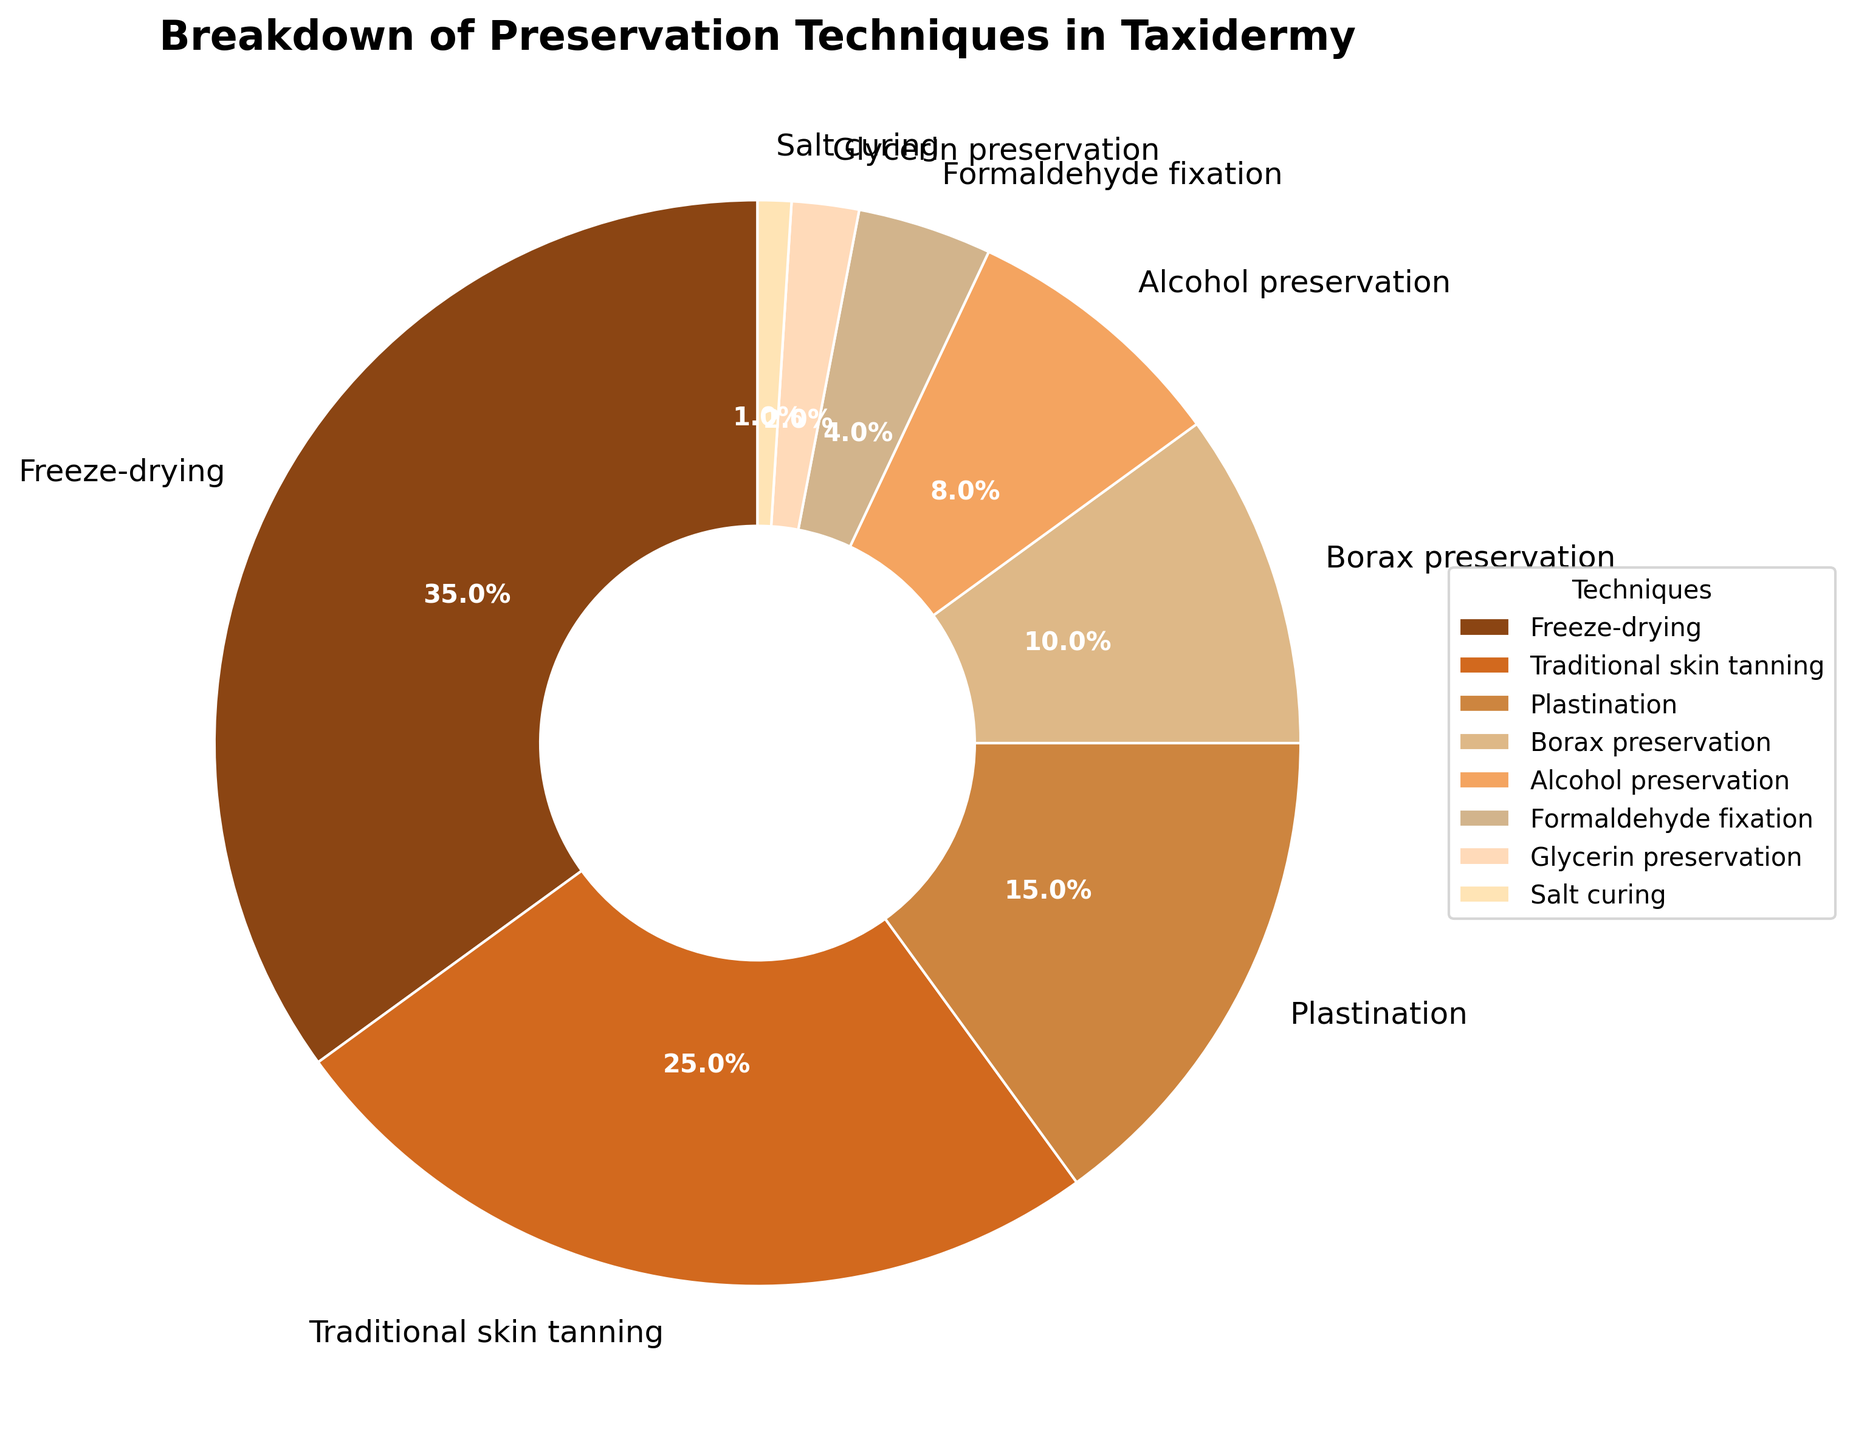What technique has the highest percentage of usage? The pie chart indicates the percentage of each preservation technique. Freeze-drying has the highest percentage slice.
Answer: Freeze-drying Which two techniques combined account for 40 percent of the total usage? First, note the percentages for each technique and find two that sum to 40. Borax preservation (10%) and Alcohol preservation (8%) together add up to 18%, so they are not the answer. Then, check Traditional skin tanning (25%) and Plastination (15%). These equal 40%.
Answer: Traditional skin tanning and Plastination How much more popular is Freeze-drying compared to Plastination? Freeze-drying has 35% usage, while Plastination has 15%. Subtract the percentage of Plastination from Freeze-drying. 35% - 15% = 20%.
Answer: 20% Which technique is represented by the color that is darkest? The pie chart uses various shades to represent different techniques. The darkest color corresponds to Freeze-drying, which is shown with the darkest brown.
Answer: Freeze-drying Are there any techniques that have a single-digit percentage, and if so, which ones? Identify techniques with percentages less than 10%. The techniques with such percentages are Alcohol preservation (8%), Formaldehyde fixation (4%), Glycerin preservation (2%), and Salt curing (1%).
Answer: Alcohol preservation, Formaldehyde fixation, Glycerin preservation, Salt curing What's the combined percentage of all the techniques with single-digit usage? Sum the percentages for Alcohol preservation (8%), Formaldehyde fixation (4%), Glycerin preservation (2%), and Salt curing (1%). 8% + 4% + 2% + 1% = 15%.
Answer: 15% What is the difference in usage percentage between Traditional skin tanning and Borax preservation? The percentage for Traditional skin tanning is 25%, and for Borax preservation is 10%. Subtract Borax preservation from Traditional skin tanning. 25% - 10% = 15%.
Answer: 15% Which preservation techniques have a higher usage percentage than Alcohol preservation? Alcohol preservation has a usage percentage of 8%. The techniques with higher usage are Freeze-drying (35%), Traditional skin tanning (25%), Plastination (15%), and Borax preservation (10%).
Answer: Freeze-drying, Traditional skin tanning, Plastination, Borax preservation 